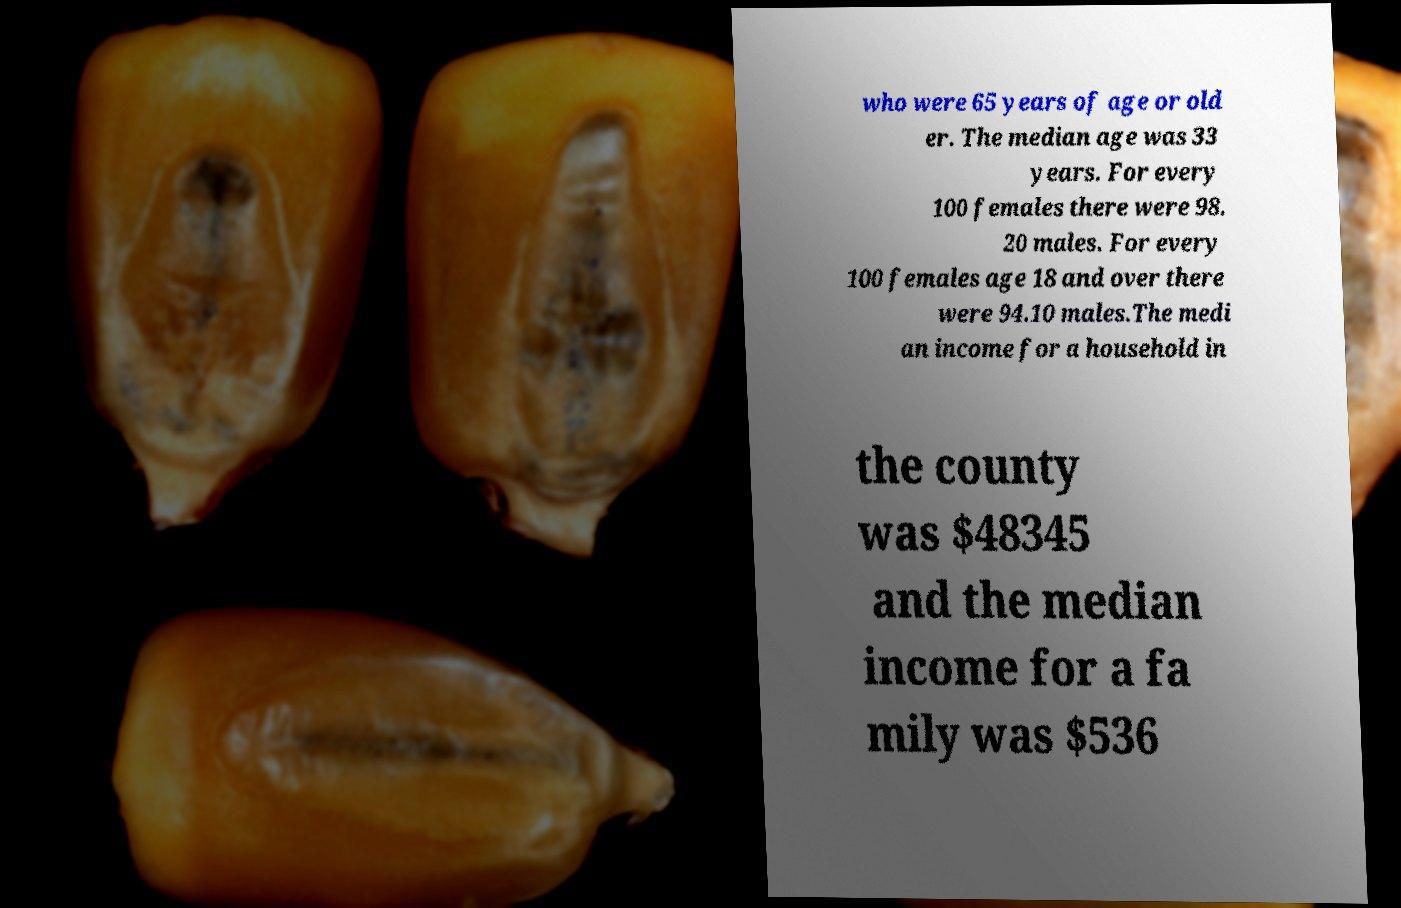What messages or text are displayed in this image? I need them in a readable, typed format. who were 65 years of age or old er. The median age was 33 years. For every 100 females there were 98. 20 males. For every 100 females age 18 and over there were 94.10 males.The medi an income for a household in the county was $48345 and the median income for a fa mily was $536 